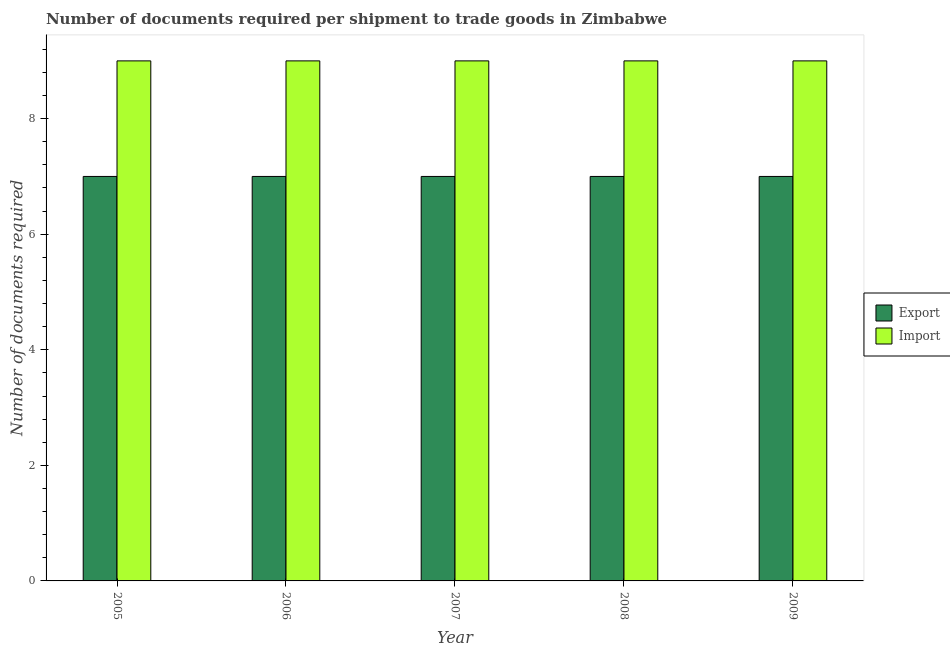How many different coloured bars are there?
Provide a short and direct response. 2. How many groups of bars are there?
Your answer should be compact. 5. Are the number of bars per tick equal to the number of legend labels?
Your answer should be compact. Yes. Are the number of bars on each tick of the X-axis equal?
Your answer should be compact. Yes. How many bars are there on the 3rd tick from the left?
Your answer should be very brief. 2. What is the label of the 5th group of bars from the left?
Give a very brief answer. 2009. What is the number of documents required to export goods in 2006?
Keep it short and to the point. 7. Across all years, what is the maximum number of documents required to import goods?
Ensure brevity in your answer.  9. Across all years, what is the minimum number of documents required to import goods?
Provide a short and direct response. 9. In which year was the number of documents required to import goods maximum?
Offer a terse response. 2005. In which year was the number of documents required to export goods minimum?
Ensure brevity in your answer.  2005. What is the total number of documents required to export goods in the graph?
Your answer should be very brief. 35. What is the difference between the number of documents required to export goods in 2005 and that in 2006?
Your response must be concise. 0. In how many years, is the number of documents required to import goods greater than 4?
Provide a succinct answer. 5. Is the number of documents required to export goods in 2006 less than that in 2009?
Offer a very short reply. No. Is the difference between the number of documents required to export goods in 2005 and 2008 greater than the difference between the number of documents required to import goods in 2005 and 2008?
Provide a succinct answer. No. In how many years, is the number of documents required to export goods greater than the average number of documents required to export goods taken over all years?
Your answer should be very brief. 0. What does the 2nd bar from the left in 2007 represents?
Give a very brief answer. Import. What does the 2nd bar from the right in 2005 represents?
Your response must be concise. Export. Are all the bars in the graph horizontal?
Give a very brief answer. No. Does the graph contain any zero values?
Offer a very short reply. No. How many legend labels are there?
Ensure brevity in your answer.  2. How are the legend labels stacked?
Offer a very short reply. Vertical. What is the title of the graph?
Ensure brevity in your answer.  Number of documents required per shipment to trade goods in Zimbabwe. What is the label or title of the Y-axis?
Keep it short and to the point. Number of documents required. What is the Number of documents required of Import in 2005?
Give a very brief answer. 9. What is the Number of documents required in Export in 2007?
Make the answer very short. 7. What is the Number of documents required in Import in 2007?
Offer a very short reply. 9. What is the Number of documents required of Export in 2008?
Provide a succinct answer. 7. Across all years, what is the maximum Number of documents required of Export?
Give a very brief answer. 7. Across all years, what is the maximum Number of documents required in Import?
Make the answer very short. 9. Across all years, what is the minimum Number of documents required of Export?
Offer a terse response. 7. What is the total Number of documents required in Export in the graph?
Your answer should be compact. 35. What is the difference between the Number of documents required in Import in 2005 and that in 2007?
Your answer should be compact. 0. What is the difference between the Number of documents required of Export in 2005 and that in 2008?
Offer a very short reply. 0. What is the difference between the Number of documents required in Import in 2005 and that in 2008?
Offer a terse response. 0. What is the difference between the Number of documents required in Export in 2005 and that in 2009?
Keep it short and to the point. 0. What is the difference between the Number of documents required of Export in 2006 and that in 2008?
Your response must be concise. 0. What is the difference between the Number of documents required in Import in 2006 and that in 2008?
Your answer should be very brief. 0. What is the difference between the Number of documents required in Import in 2007 and that in 2008?
Your answer should be very brief. 0. What is the difference between the Number of documents required in Export in 2008 and that in 2009?
Provide a succinct answer. 0. What is the difference between the Number of documents required in Export in 2005 and the Number of documents required in Import in 2008?
Your response must be concise. -2. What is the difference between the Number of documents required of Export in 2005 and the Number of documents required of Import in 2009?
Offer a terse response. -2. What is the difference between the Number of documents required of Export in 2006 and the Number of documents required of Import in 2008?
Provide a short and direct response. -2. What is the difference between the Number of documents required in Export in 2006 and the Number of documents required in Import in 2009?
Offer a very short reply. -2. What is the difference between the Number of documents required of Export in 2007 and the Number of documents required of Import in 2008?
Provide a succinct answer. -2. What is the average Number of documents required of Import per year?
Provide a short and direct response. 9. In the year 2007, what is the difference between the Number of documents required in Export and Number of documents required in Import?
Your answer should be compact. -2. In the year 2008, what is the difference between the Number of documents required of Export and Number of documents required of Import?
Your answer should be very brief. -2. What is the ratio of the Number of documents required of Import in 2005 to that in 2006?
Give a very brief answer. 1. What is the ratio of the Number of documents required in Export in 2005 to that in 2007?
Offer a terse response. 1. What is the ratio of the Number of documents required of Import in 2005 to that in 2008?
Offer a very short reply. 1. What is the ratio of the Number of documents required in Export in 2005 to that in 2009?
Give a very brief answer. 1. What is the ratio of the Number of documents required in Import in 2005 to that in 2009?
Provide a succinct answer. 1. What is the ratio of the Number of documents required of Export in 2006 to that in 2009?
Provide a short and direct response. 1. What is the ratio of the Number of documents required in Import in 2006 to that in 2009?
Provide a short and direct response. 1. What is the ratio of the Number of documents required of Export in 2007 to that in 2009?
Ensure brevity in your answer.  1. What is the difference between the highest and the second highest Number of documents required in Export?
Ensure brevity in your answer.  0. What is the difference between the highest and the second highest Number of documents required in Import?
Your answer should be very brief. 0. What is the difference between the highest and the lowest Number of documents required in Export?
Offer a terse response. 0. What is the difference between the highest and the lowest Number of documents required in Import?
Make the answer very short. 0. 